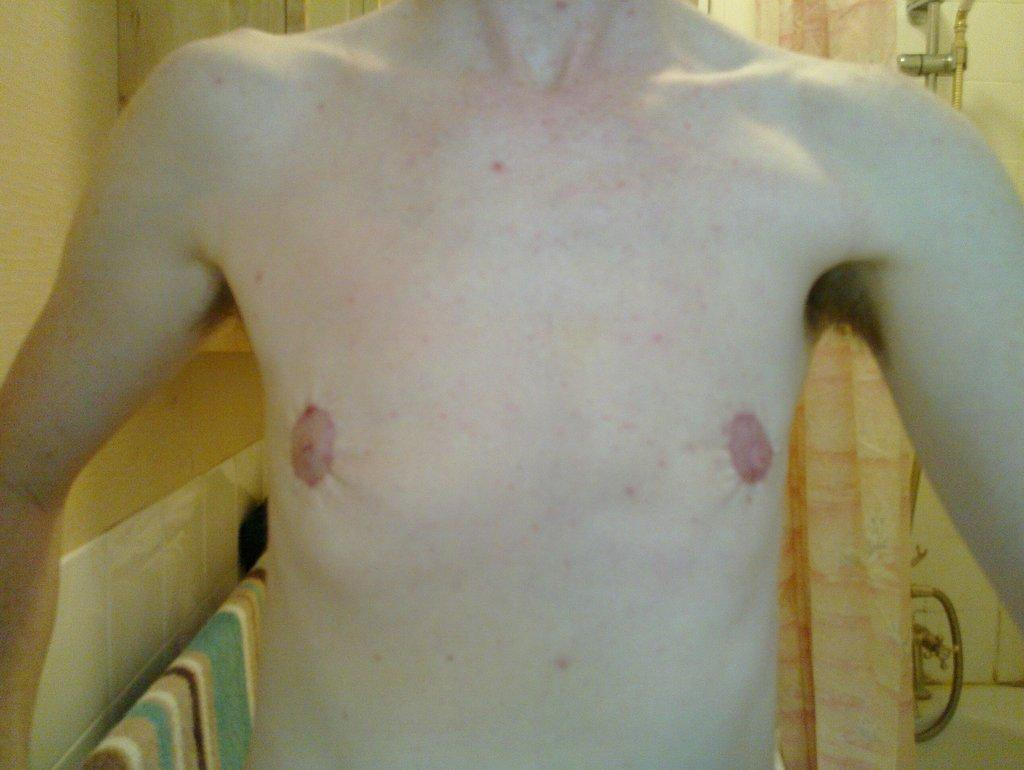What is the main subject of the image? There is a person in the image. Can you describe the background of the image? There are pipes in the background of the image. What type of trousers is the group wearing in the image? There is no group present in the image, and therefore no trousers can be observed. 